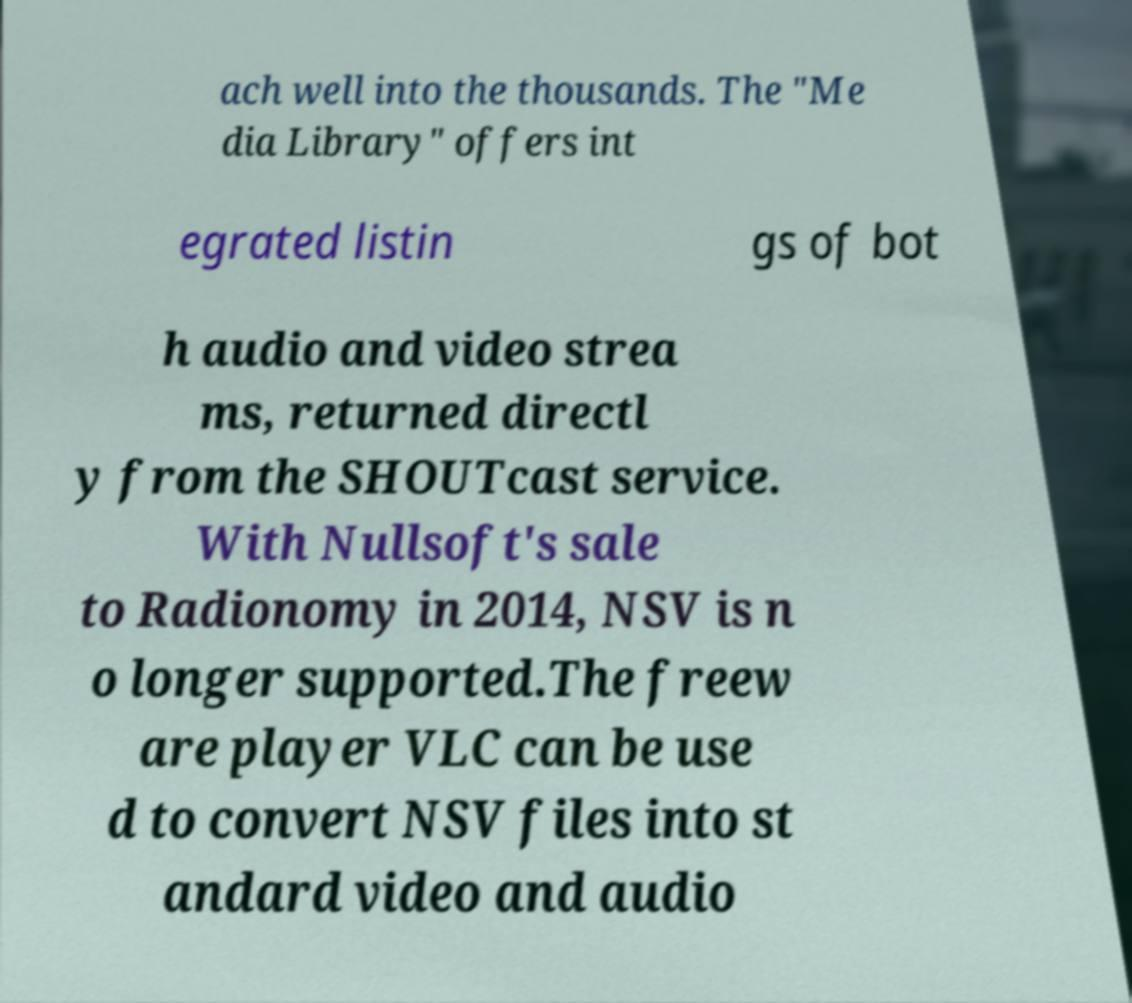What messages or text are displayed in this image? I need them in a readable, typed format. ach well into the thousands. The "Me dia Library" offers int egrated listin gs of bot h audio and video strea ms, returned directl y from the SHOUTcast service. With Nullsoft's sale to Radionomy in 2014, NSV is n o longer supported.The freew are player VLC can be use d to convert NSV files into st andard video and audio 